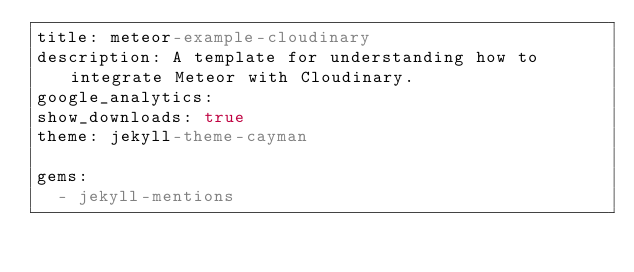<code> <loc_0><loc_0><loc_500><loc_500><_YAML_>title: meteor-example-cloudinary
description: A template for understanding how to integrate Meteor with Cloudinary.
google_analytics: 
show_downloads: true
theme: jekyll-theme-cayman

gems:
  - jekyll-mentions
</code> 